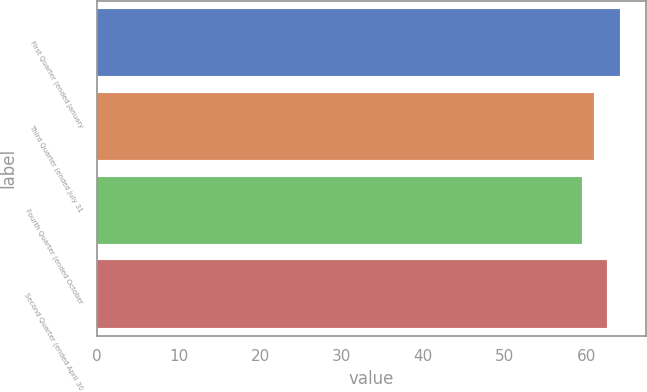Convert chart. <chart><loc_0><loc_0><loc_500><loc_500><bar_chart><fcel>First Quarter (ended January<fcel>Third Quarter (ended July 31<fcel>Fourth Quarter (ended October<fcel>Second Quarter (ended April 30<nl><fcel>64.11<fcel>60.97<fcel>59.4<fcel>62.54<nl></chart> 